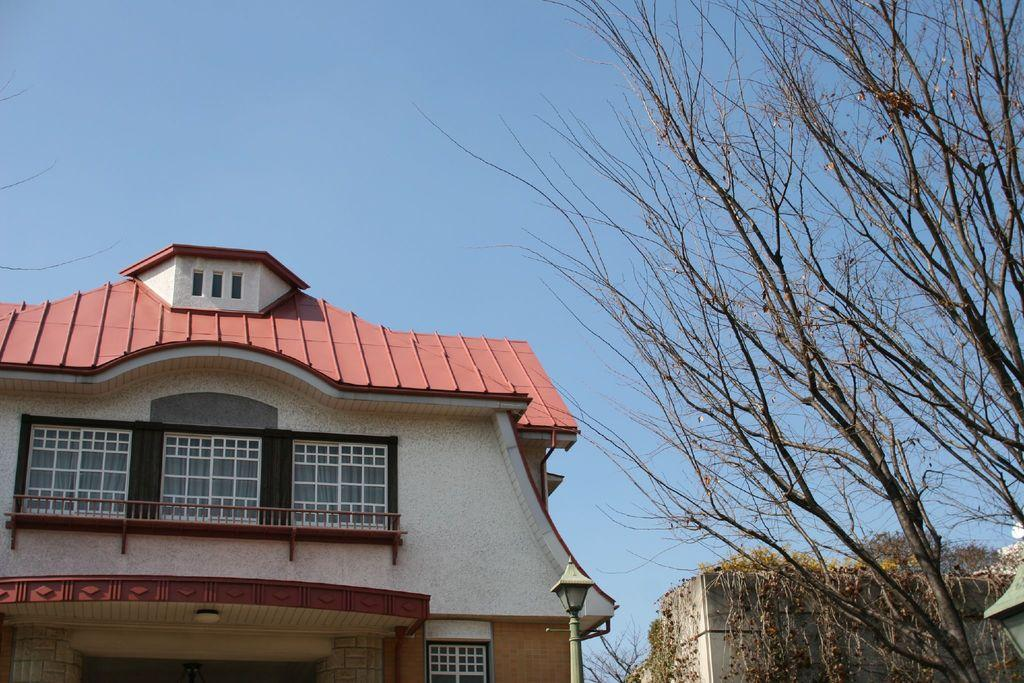What type of structure is present in the image? There is a building in the image. What feature can be seen on the building? The building has windows. What other object is visible in the image? There is a pole in the image. What type of natural elements are present in the image? There are trees in the image. What can be seen in the background of the image? The sky is visible in the background of the image. What type of joke is being told by the clock in the image? There is no clock present in the image, and therefore no joke can be told by a clock. Can you see a chess game being played in the image? There is no chess game visible in the image. 